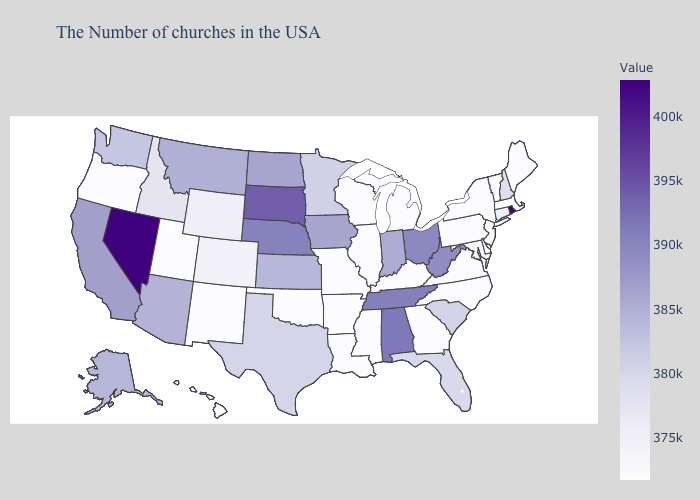Does Indiana have the lowest value in the USA?
Give a very brief answer. No. Is the legend a continuous bar?
Keep it brief. Yes. 